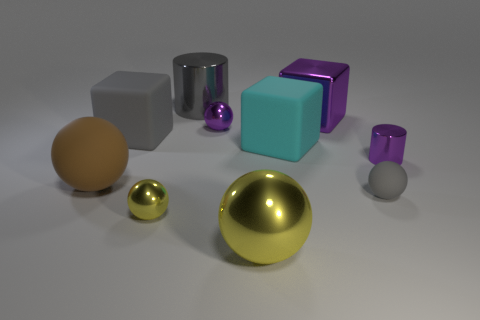Subtract all brown spheres. How many spheres are left? 4 Subtract all large yellow metal balls. How many balls are left? 4 Subtract all cyan spheres. Subtract all red cubes. How many spheres are left? 5 Subtract all cubes. How many objects are left? 7 Subtract all large metallic balls. Subtract all gray blocks. How many objects are left? 8 Add 4 tiny gray matte objects. How many tiny gray matte objects are left? 5 Add 6 big yellow metallic objects. How many big yellow metallic objects exist? 7 Subtract 0 red cubes. How many objects are left? 10 